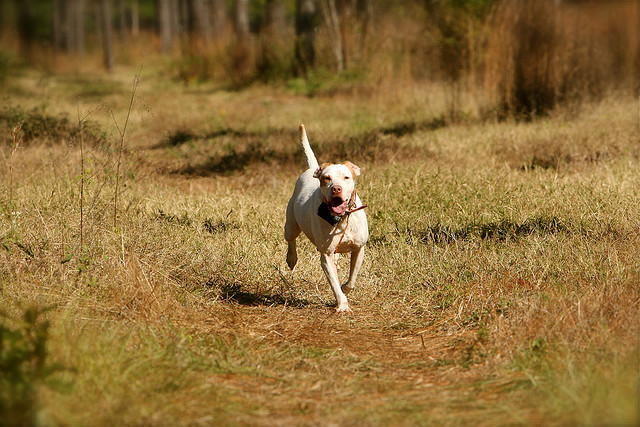<image>What is the dig playing with? I don't know what the dog is playing with. It seems to be either a ball or a stick, or maybe nothing at all. What is the dig playing with? I don't know what the dog is playing with. It could be a ball or a stick. 